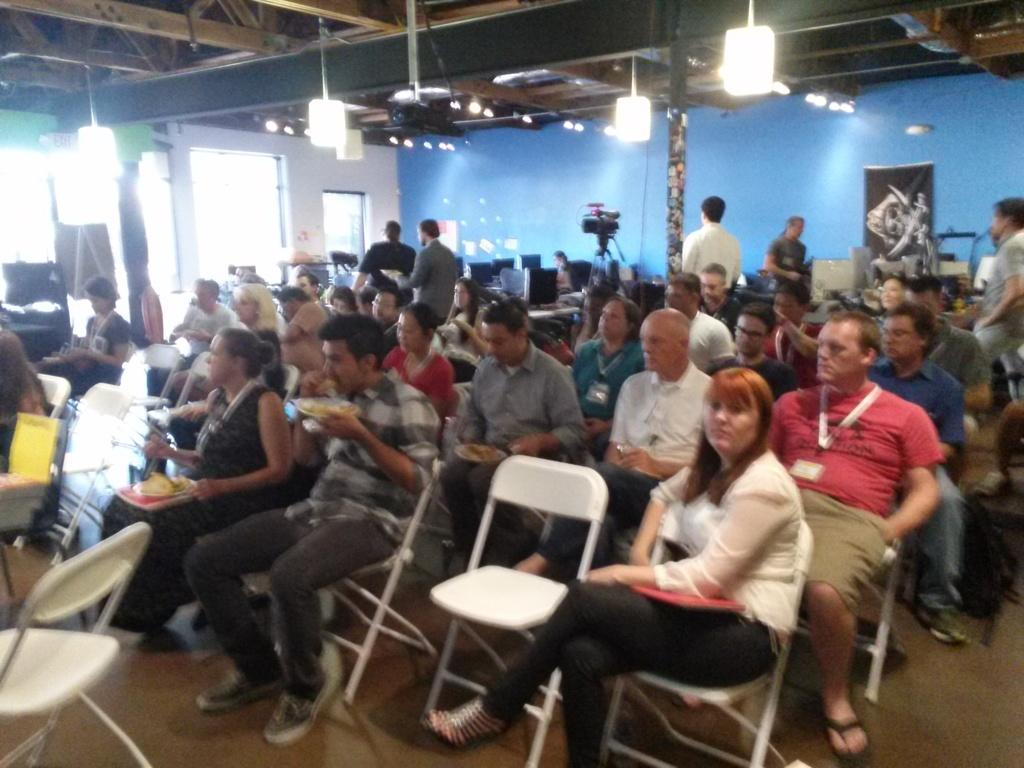What is the main subject of the image? The main subject of the image is a group of people. What are the people in the image doing? The people are sitting on a chair. What can be seen in the background or surrounding the people? There are lights visible in the image, and there is a blue color wall in the image. How many servants are attending to the group of people in the image? There is no mention of servants in the image, so we cannot determine their presence or number. 